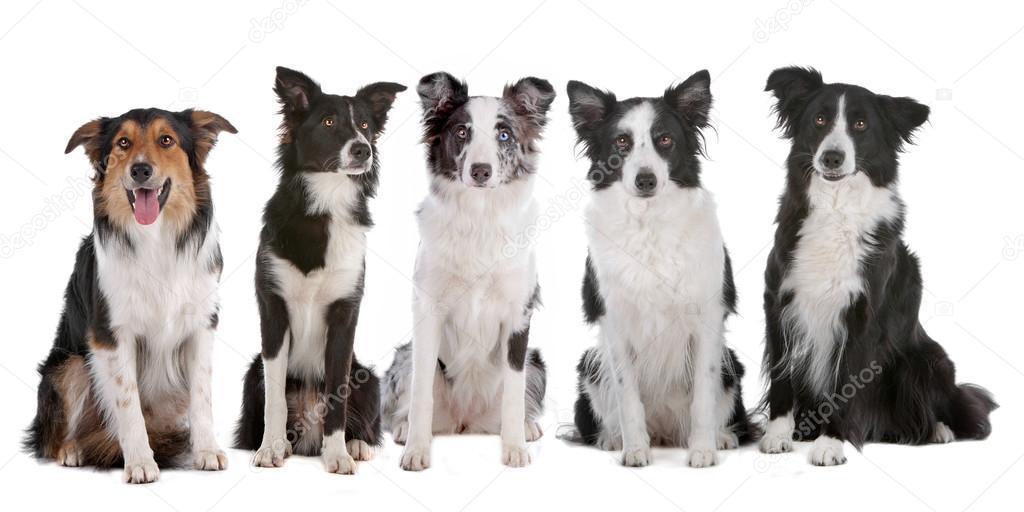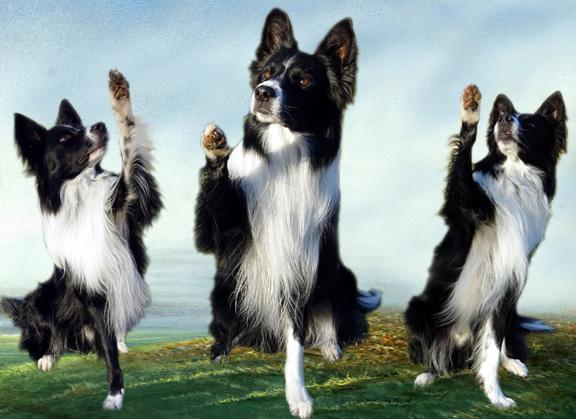The first image is the image on the left, the second image is the image on the right. For the images shown, is this caption "There are no more than two dogs." true? Answer yes or no. No. The first image is the image on the left, the second image is the image on the right. Evaluate the accuracy of this statement regarding the images: "There are visible paw prints in the snow in both images.". Is it true? Answer yes or no. No. 